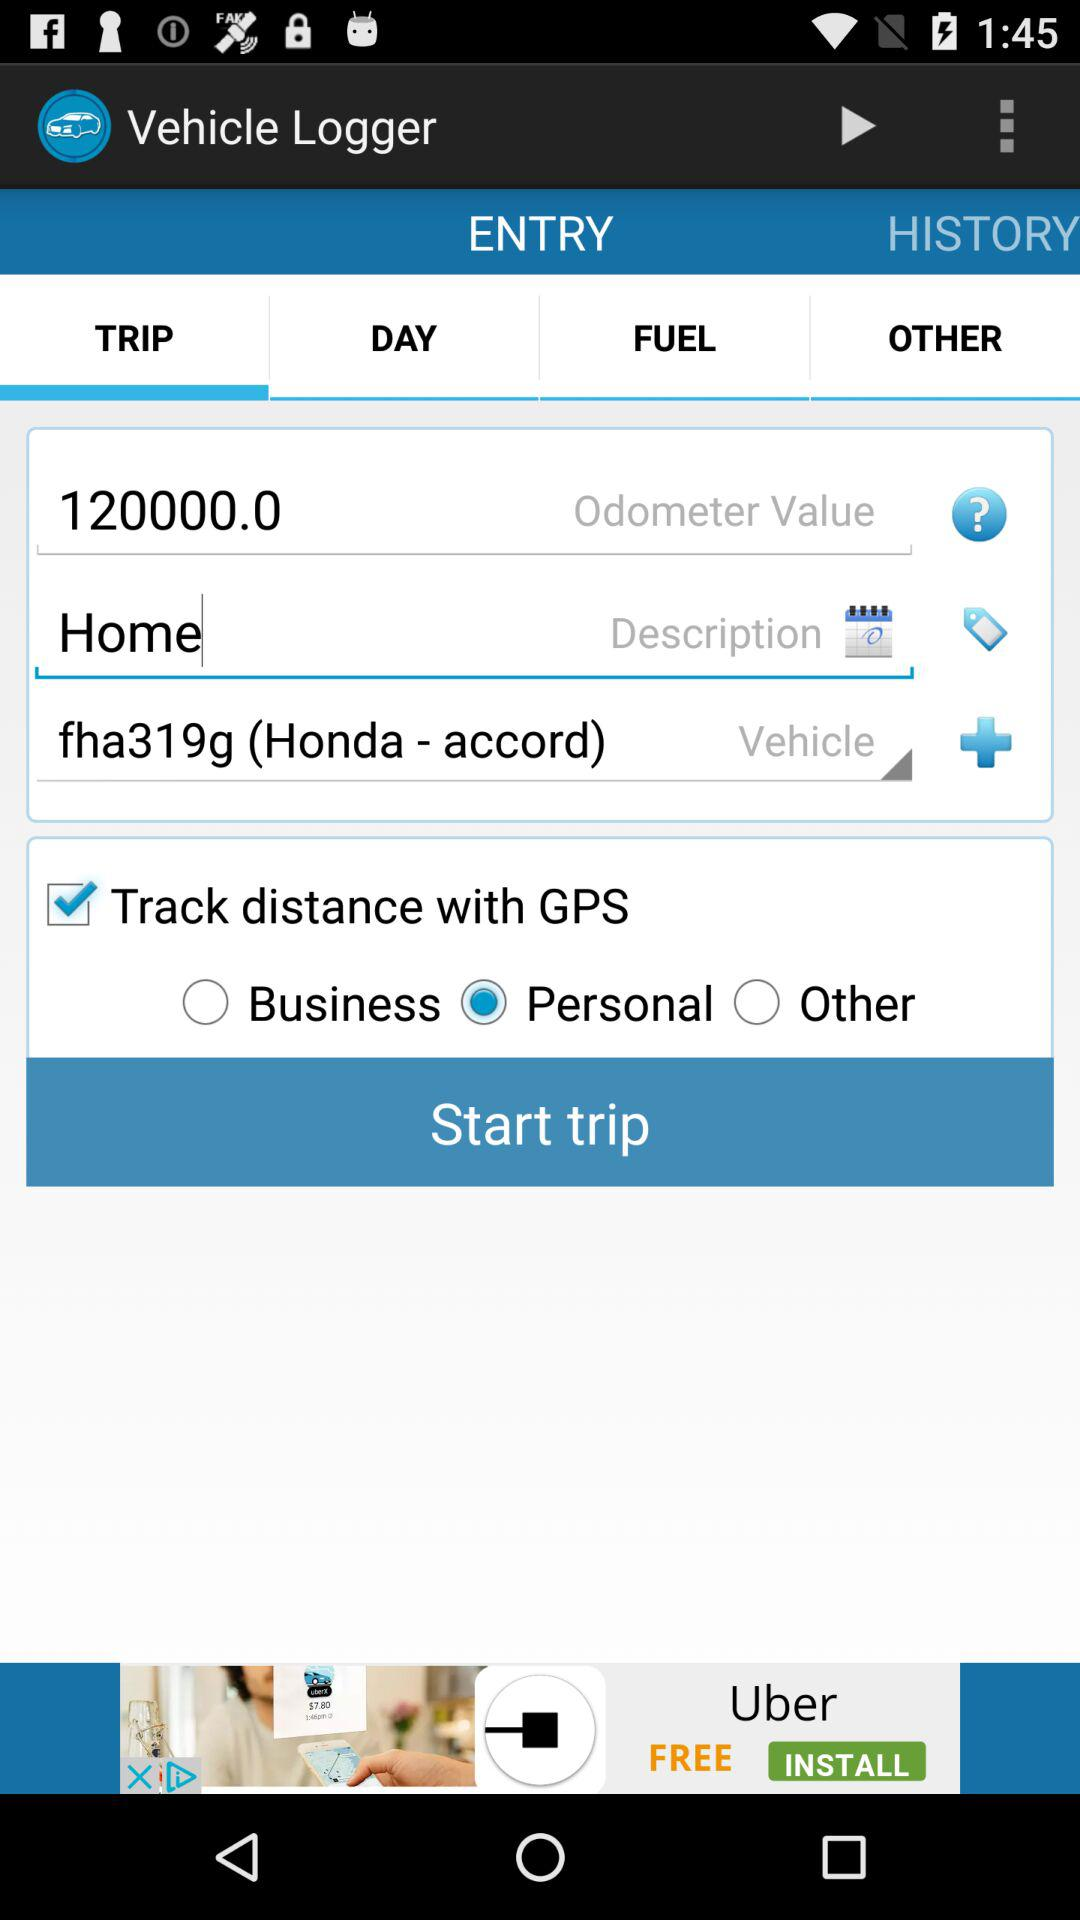What is the odometer value?
Answer the question using a single word or phrase. 120000.0 